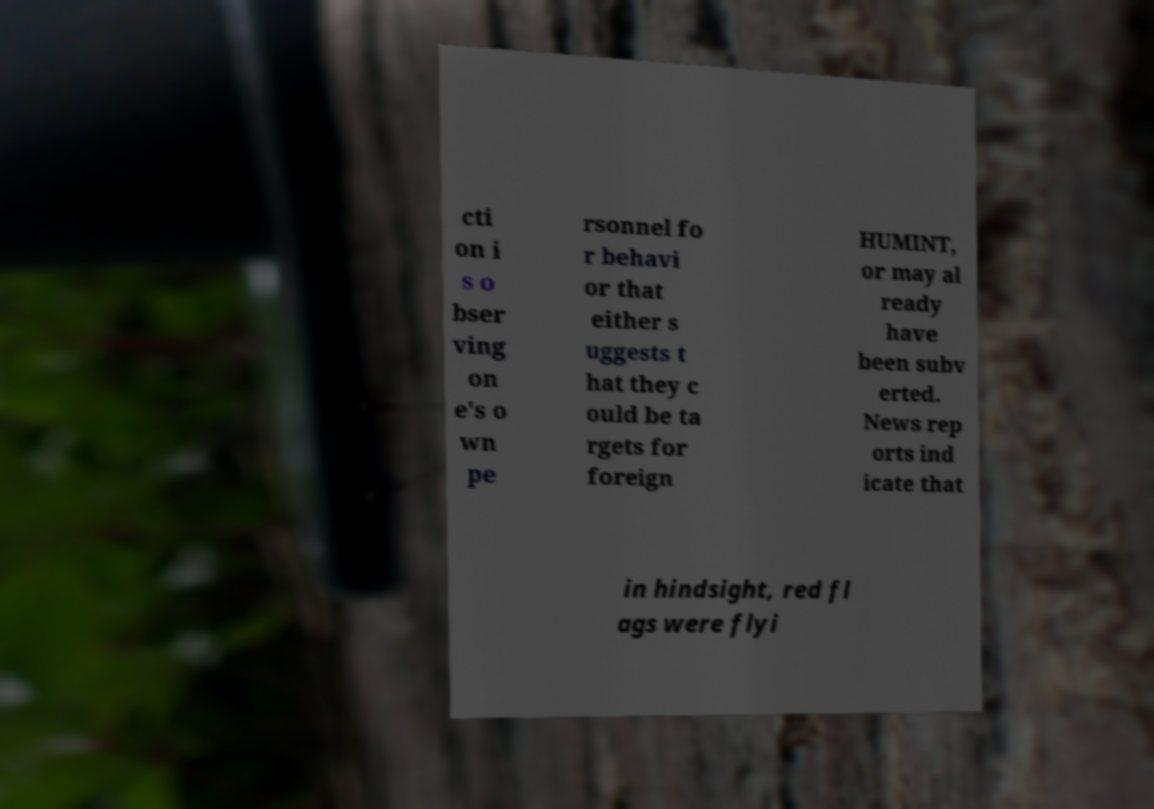There's text embedded in this image that I need extracted. Can you transcribe it verbatim? cti on i s o bser ving on e's o wn pe rsonnel fo r behavi or that either s uggests t hat they c ould be ta rgets for foreign HUMINT, or may al ready have been subv erted. News rep orts ind icate that in hindsight, red fl ags were flyi 